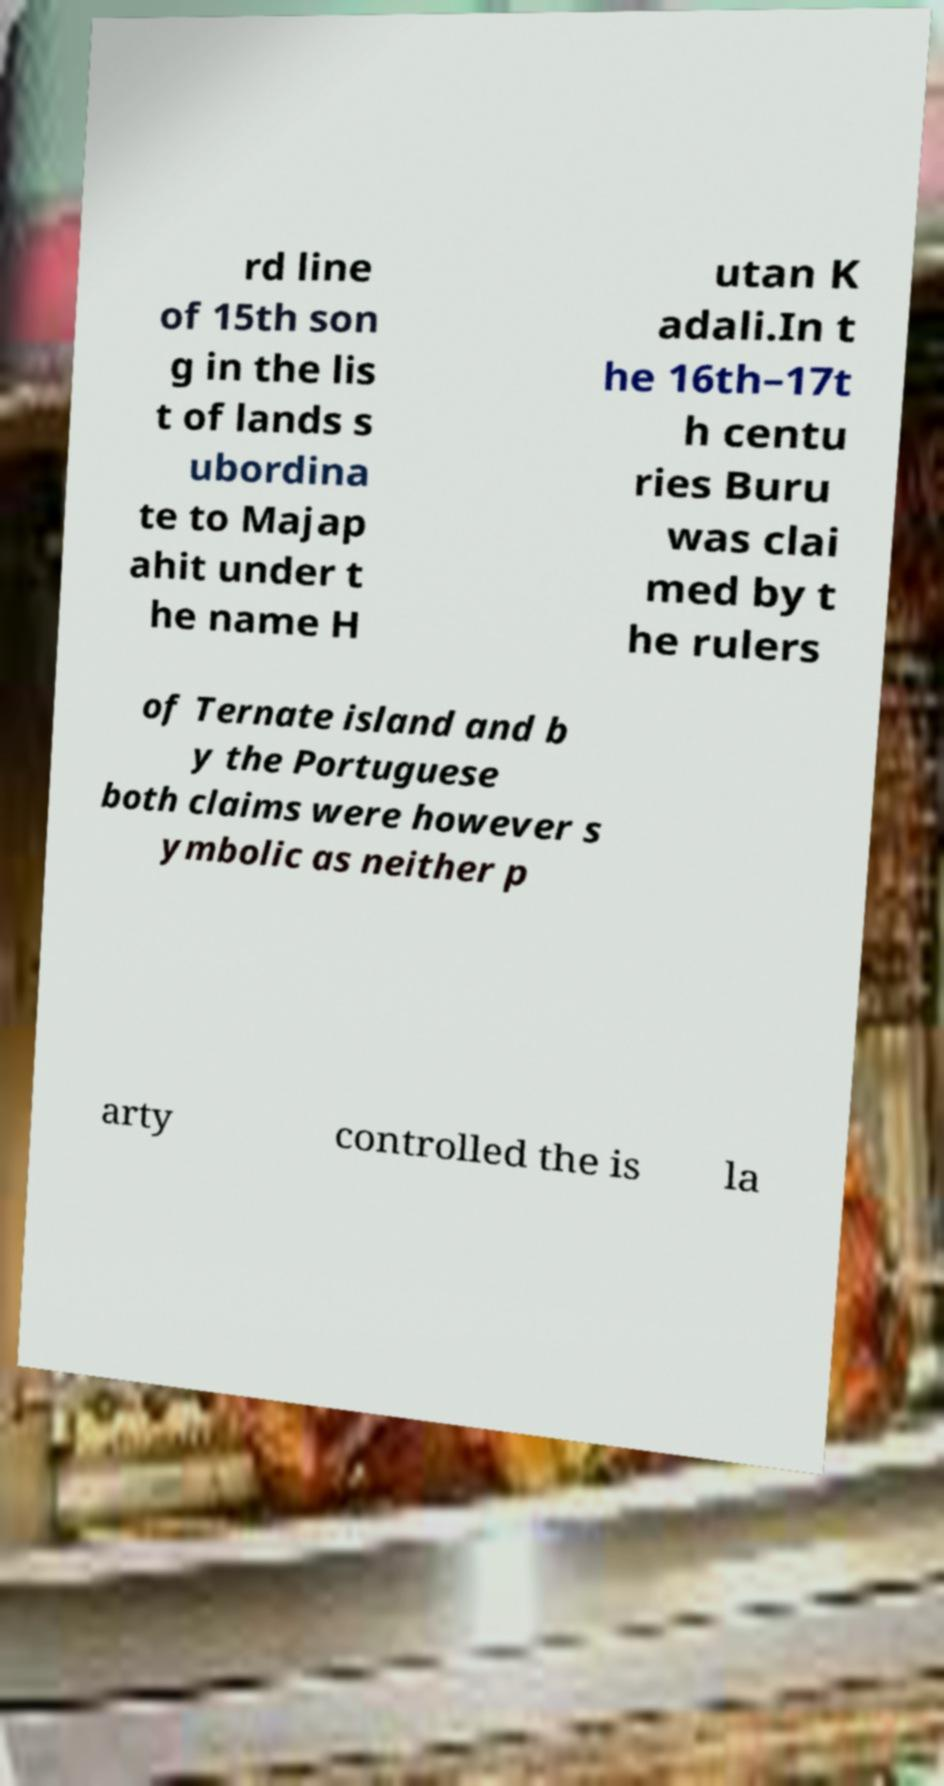For documentation purposes, I need the text within this image transcribed. Could you provide that? rd line of 15th son g in the lis t of lands s ubordina te to Majap ahit under t he name H utan K adali.In t he 16th–17t h centu ries Buru was clai med by t he rulers of Ternate island and b y the Portuguese both claims were however s ymbolic as neither p arty controlled the is la 